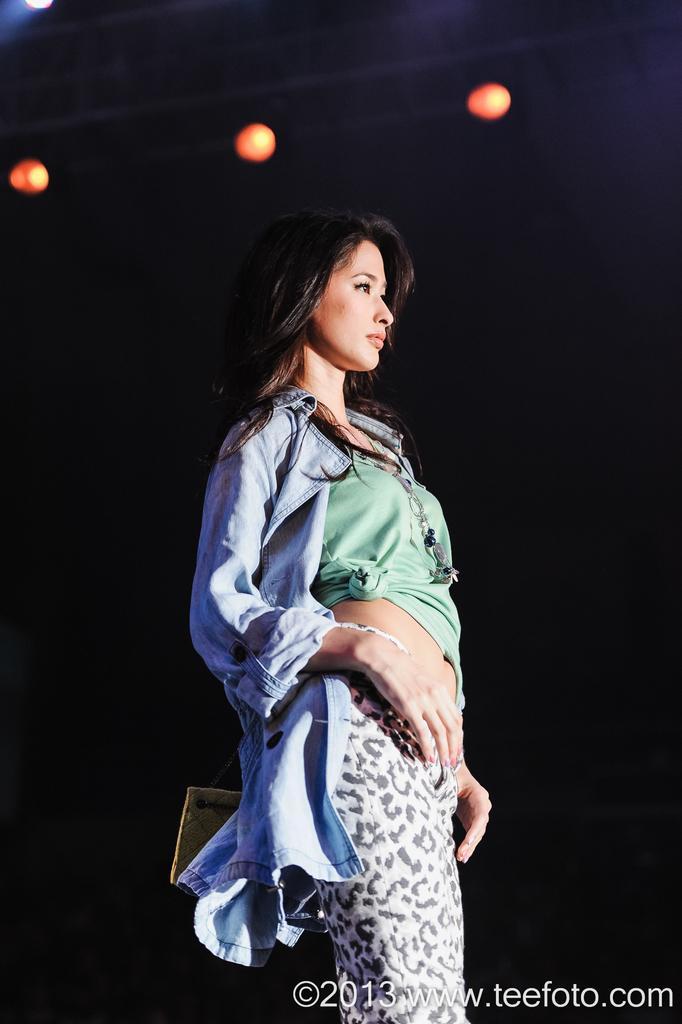Can you describe this image briefly? In the center of the image a lady is there. At the top of the image we can see some lights are present. 